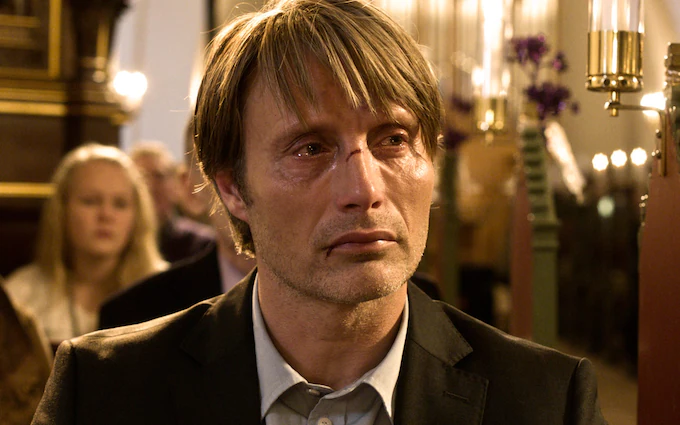Describe the atmosphere conveyed by the lighting and surroundings in the image. The image captures a church interior bathed in soft, diffuse light that highlights the golden tones of the wood and metallic fixtures. This lighting creates a serene yet somber atmosphere, which is accentuated by the blurred background, focusing attention on the emotional state of the person in the foreground. The subtle but rich lighting suggests a setting that is both historic and charged with emotional depth. 